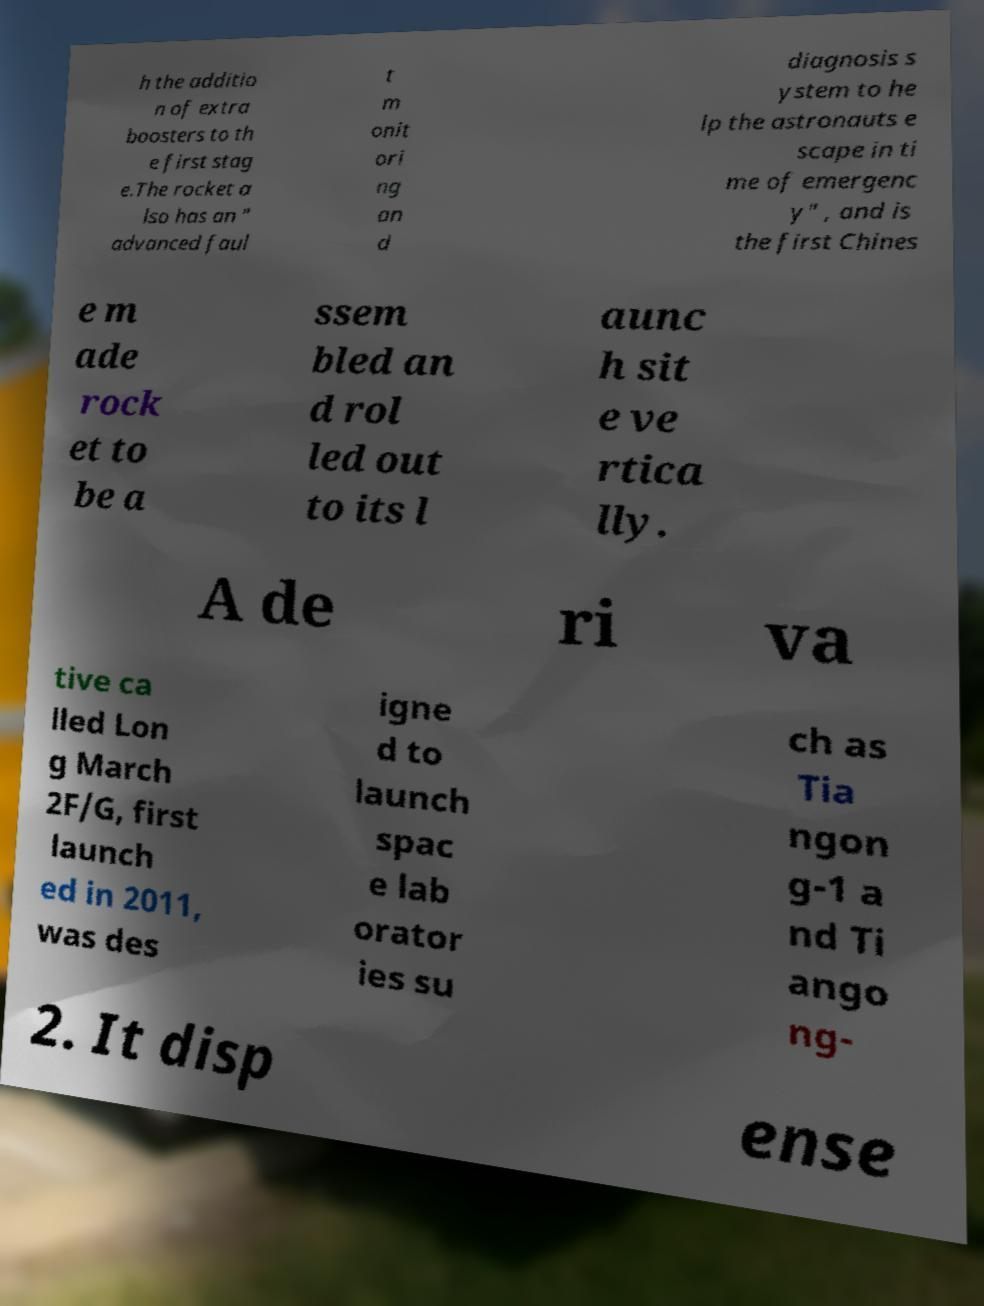There's text embedded in this image that I need extracted. Can you transcribe it verbatim? h the additio n of extra boosters to th e first stag e.The rocket a lso has an " advanced faul t m onit ori ng an d diagnosis s ystem to he lp the astronauts e scape in ti me of emergenc y" , and is the first Chines e m ade rock et to be a ssem bled an d rol led out to its l aunc h sit e ve rtica lly. A de ri va tive ca lled Lon g March 2F/G, first launch ed in 2011, was des igne d to launch spac e lab orator ies su ch as Tia ngon g-1 a nd Ti ango ng- 2. It disp ense 